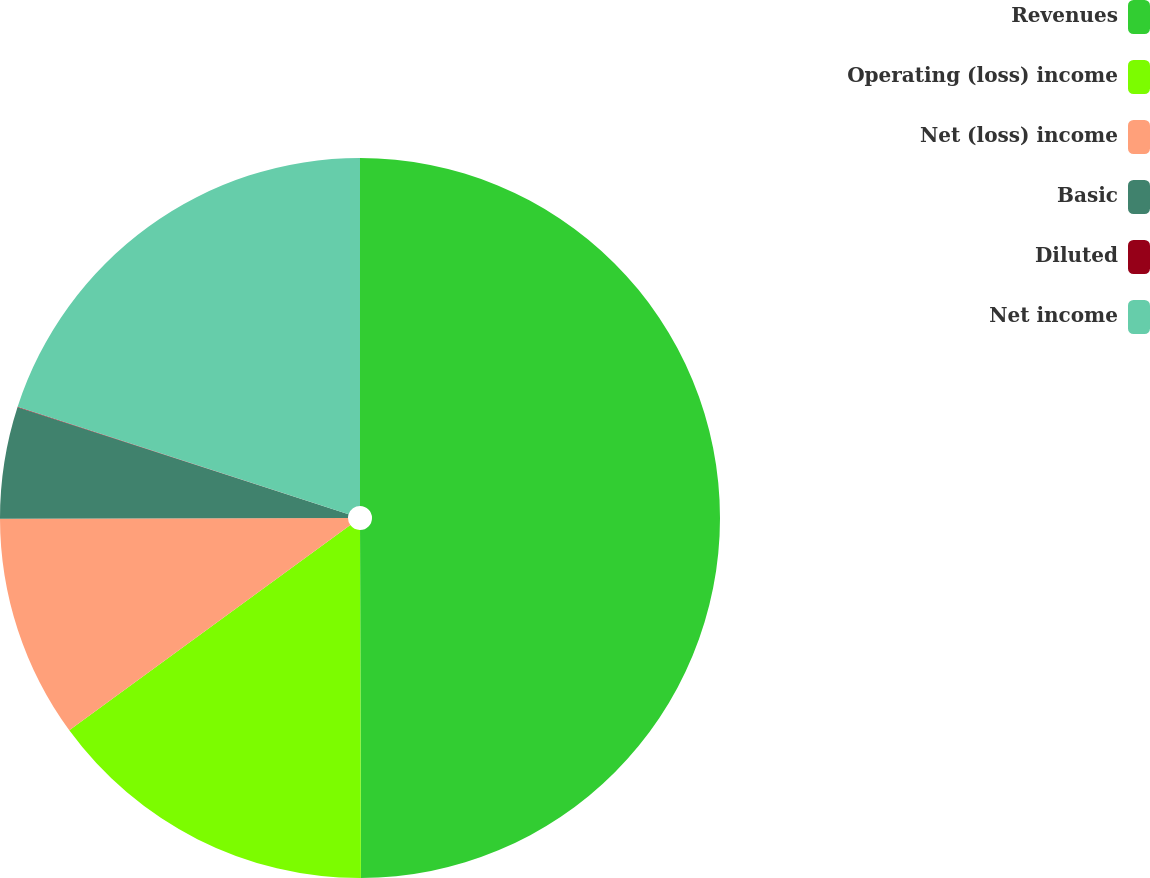Convert chart. <chart><loc_0><loc_0><loc_500><loc_500><pie_chart><fcel>Revenues<fcel>Operating (loss) income<fcel>Net (loss) income<fcel>Basic<fcel>Diluted<fcel>Net income<nl><fcel>49.96%<fcel>15.0%<fcel>10.01%<fcel>5.01%<fcel>0.02%<fcel>20.0%<nl></chart> 